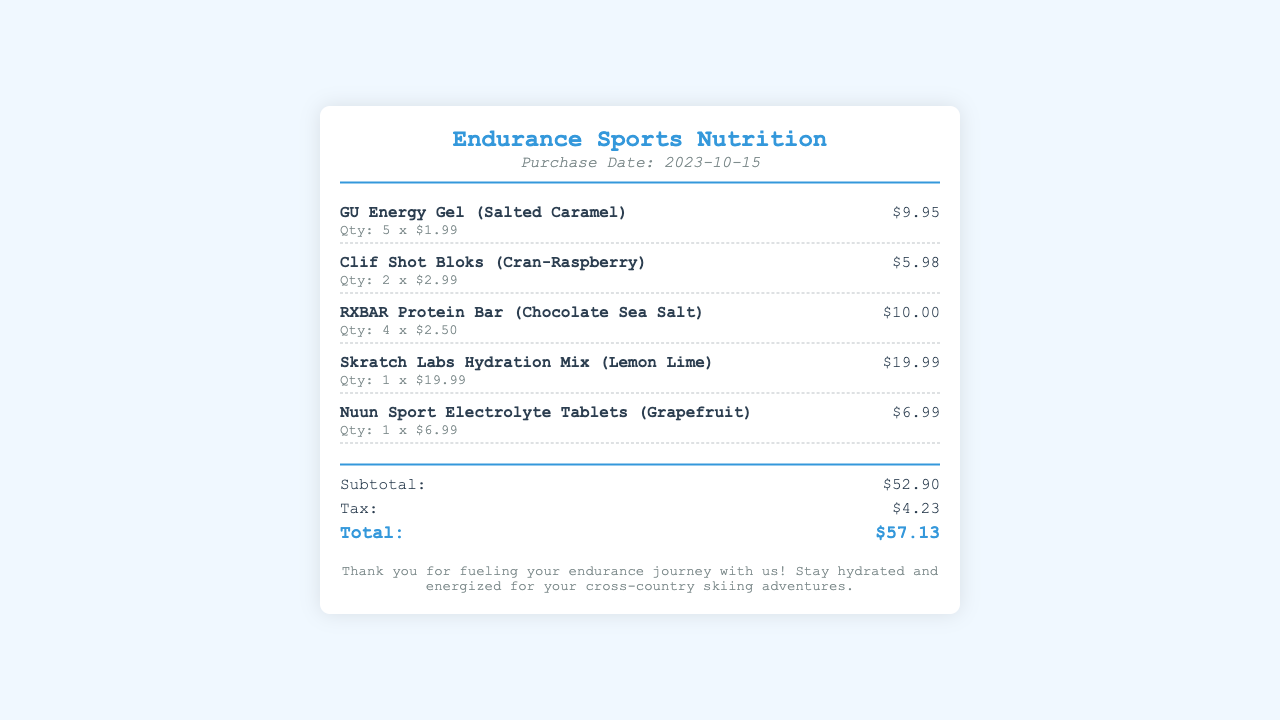What is the store name? The store name is located at the top of the receipt.
Answer: Endurance Sports Nutrition What was the purchase date? The purchase date is noted in the header of the receipt.
Answer: 2023-10-15 How many GU Energy Gels were purchased? The quantity of GU Energy Gels is listed next to the item name in the items section.
Answer: 5 What is the price of a Clif Shot Bloks? The price per Clif Shot Bloks is indicated in the item details.
Answer: $2.99 What is the subtotal of the items? The subtotal is clearly listed in the totals section of the receipt.
Answer: $52.90 What is the total amount after tax? The total amount is mentioned at the end of the totals section.
Answer: $57.13 Which protein bar is listed in the purchase? The specific name of the protein bar is noted under the item section.
Answer: RXBAR Protein Bar (Chocolate Sea Salt) How many types of electrolyte products are included in the receipt? The electrolyte products are listed under the items section; counting them yields the answer.
Answer: 2 What was included in the footer of the receipt? The footer provides closing statements about hydration and fueling endurance.
Answer: Thank you for fueling your endurance journey with us! 